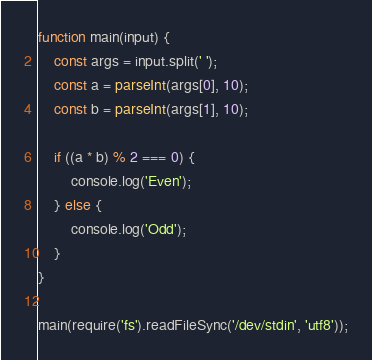Convert code to text. <code><loc_0><loc_0><loc_500><loc_500><_JavaScript_>function main(input) {
    const args = input.split(' ');
    const a = parseInt(args[0], 10);
    const b = parseInt(args[1], 10);

    if ((a * b) % 2 === 0) {
        console.log('Even');
    } else {
        console.log('Odd');
    }
}

main(require('fs').readFileSync('/dev/stdin', 'utf8'));</code> 